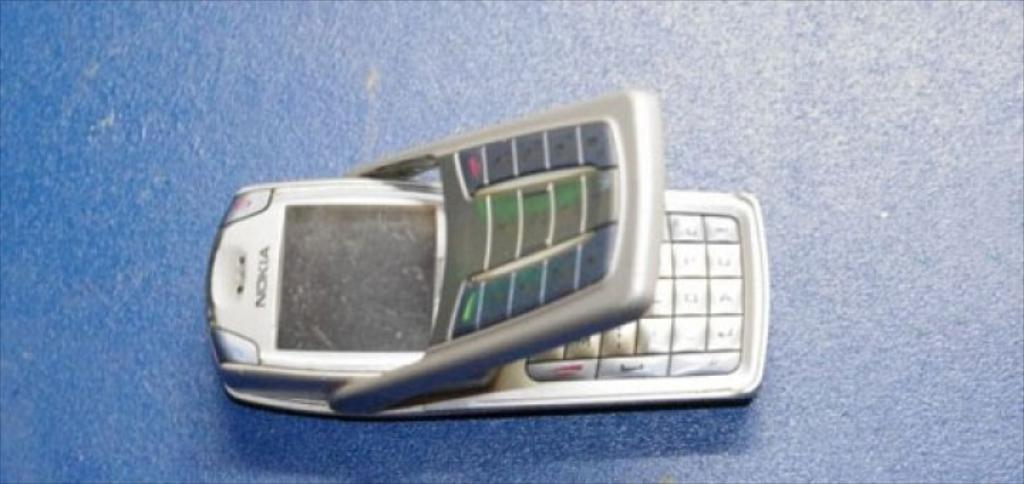<image>
Relay a brief, clear account of the picture shown. The phone shown on the blue counter is an old style flip nokia phone. 